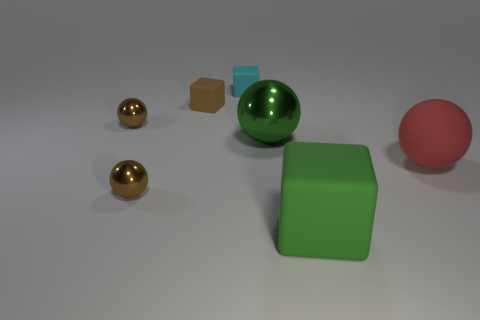Add 3 purple matte cylinders. How many objects exist? 10 Subtract all small cyan rubber cubes. How many cubes are left? 2 Add 4 shiny things. How many shiny things are left? 7 Add 5 large rubber things. How many large rubber things exist? 7 Subtract all green balls. How many balls are left? 3 Subtract 1 red balls. How many objects are left? 6 Subtract all balls. How many objects are left? 3 Subtract 3 blocks. How many blocks are left? 0 Subtract all cyan cubes. Subtract all cyan cylinders. How many cubes are left? 2 Subtract all gray cylinders. How many brown cubes are left? 1 